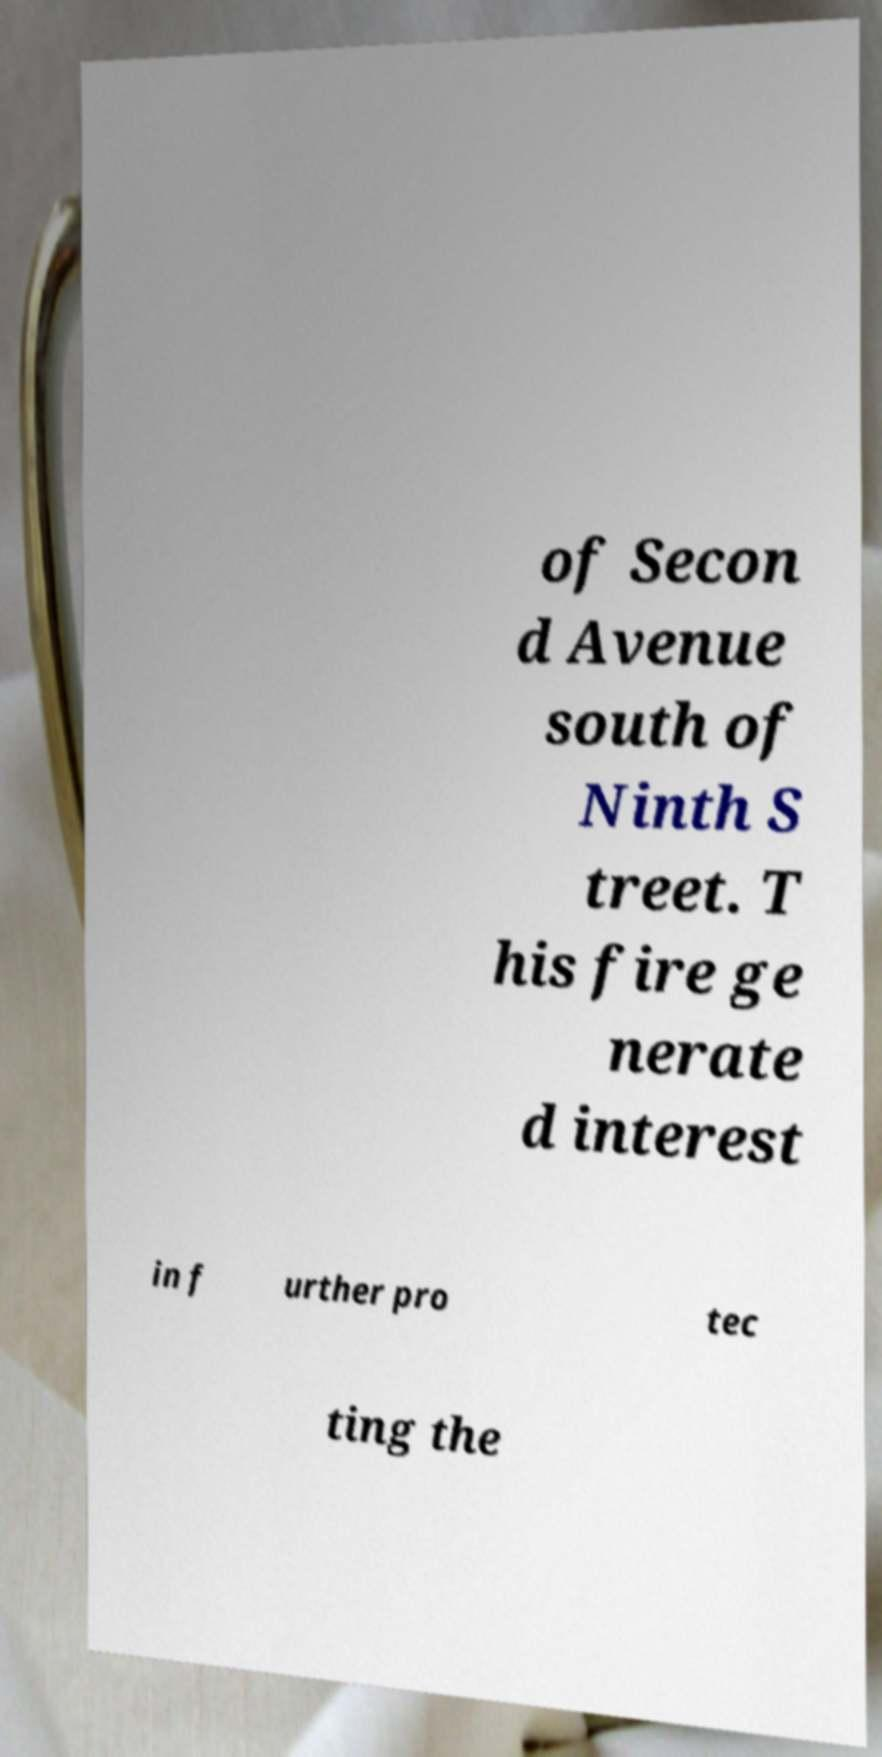Please read and relay the text visible in this image. What does it say? of Secon d Avenue south of Ninth S treet. T his fire ge nerate d interest in f urther pro tec ting the 